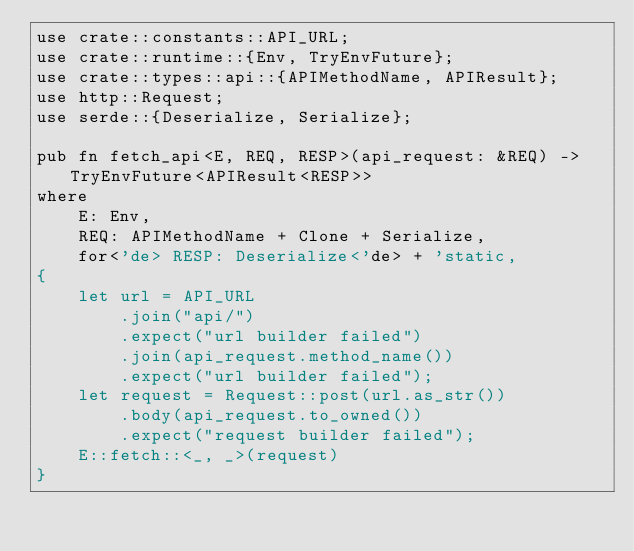<code> <loc_0><loc_0><loc_500><loc_500><_Rust_>use crate::constants::API_URL;
use crate::runtime::{Env, TryEnvFuture};
use crate::types::api::{APIMethodName, APIResult};
use http::Request;
use serde::{Deserialize, Serialize};

pub fn fetch_api<E, REQ, RESP>(api_request: &REQ) -> TryEnvFuture<APIResult<RESP>>
where
    E: Env,
    REQ: APIMethodName + Clone + Serialize,
    for<'de> RESP: Deserialize<'de> + 'static,
{
    let url = API_URL
        .join("api/")
        .expect("url builder failed")
        .join(api_request.method_name())
        .expect("url builder failed");
    let request = Request::post(url.as_str())
        .body(api_request.to_owned())
        .expect("request builder failed");
    E::fetch::<_, _>(request)
}
</code> 